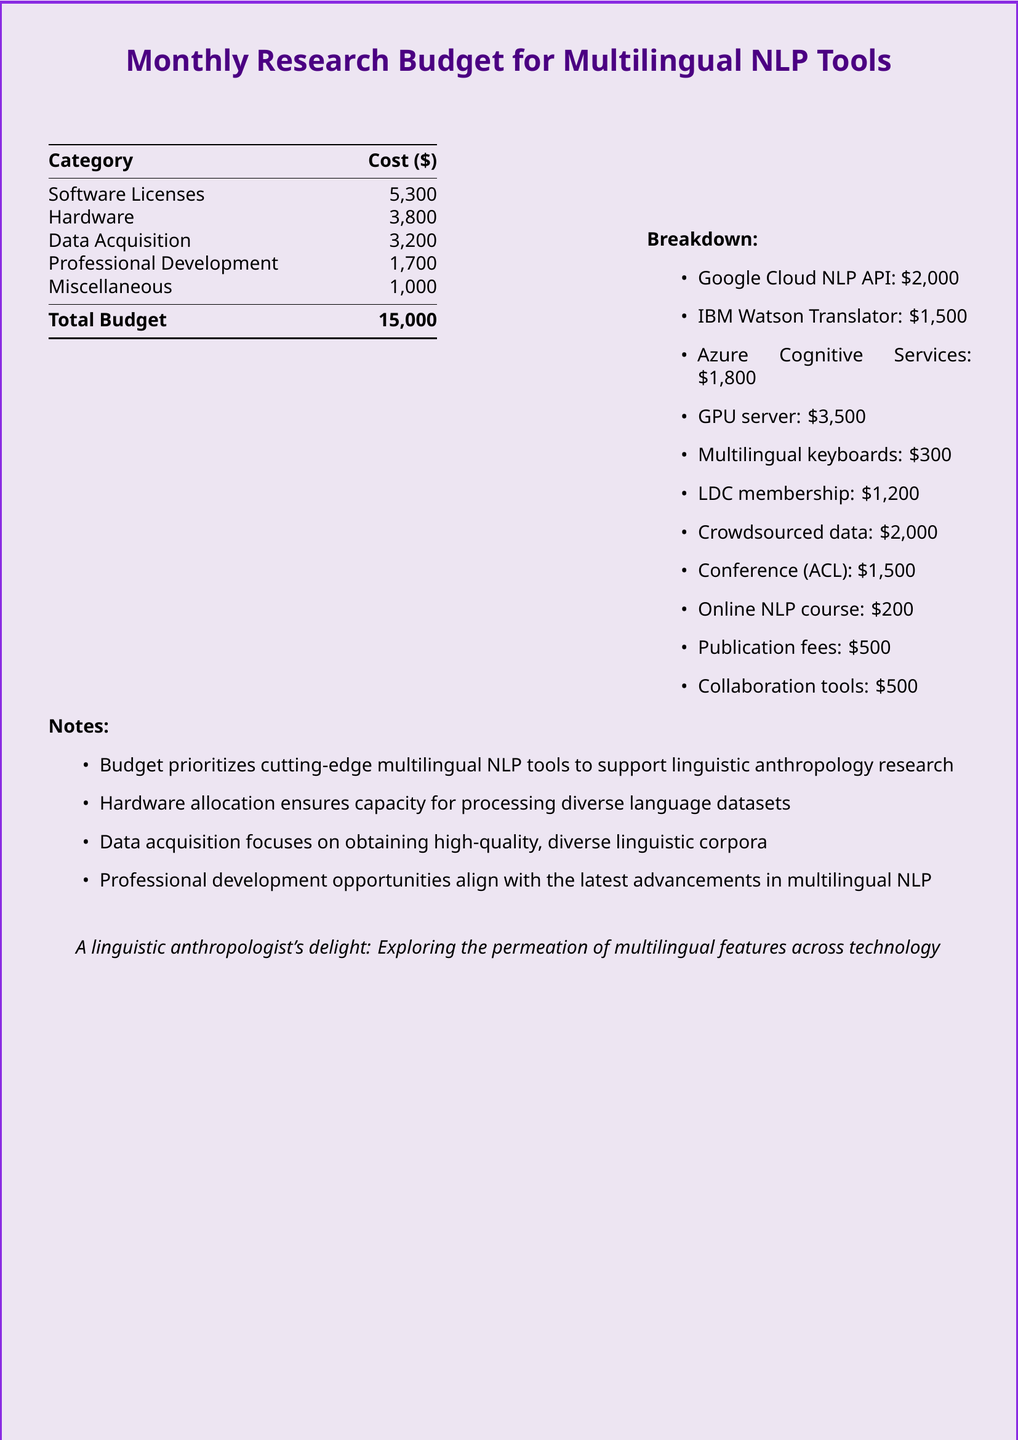What is the total budget? The total budget is the sum of all costs listed in the budget table.
Answer: 15,000 How much is allocated for software licenses? The budget table lists software licenses under the "Category" column with its corresponding cost.
Answer: 5,300 What is the cost for the GPU server? The breakdown section specifically lists the GPU server with its associated cost.
Answer: 3,500 How much is allocated for professional development? The budget table shows the amount budgeted under the "Professional Development" category.
Answer: 1,700 What is the cost of the Azure Cognitive Services? The breakdown section includes Azure Cognitive Services and its cost.
Answer: 1,800 What percentage of the total budget is allocated for data acquisition? To find the percentage, divide the data acquisition cost by the total budget and multiply by 100.
Answer: 21.33% How many items are listed in the breakdown section? The breakdown section consists of specific items that are enumerated, which can be counted.
Answer: 11 Which item costs the least in the breakdown? The breakdown section lists all items with their costs, allowing you to identify the smallest cost.
Answer: 200 What is the purpose of the professional development allocation? The notes section mentions the aim of professional development opportunities in the context of the budget.
Answer: Latest advancements in multilingual NLP 